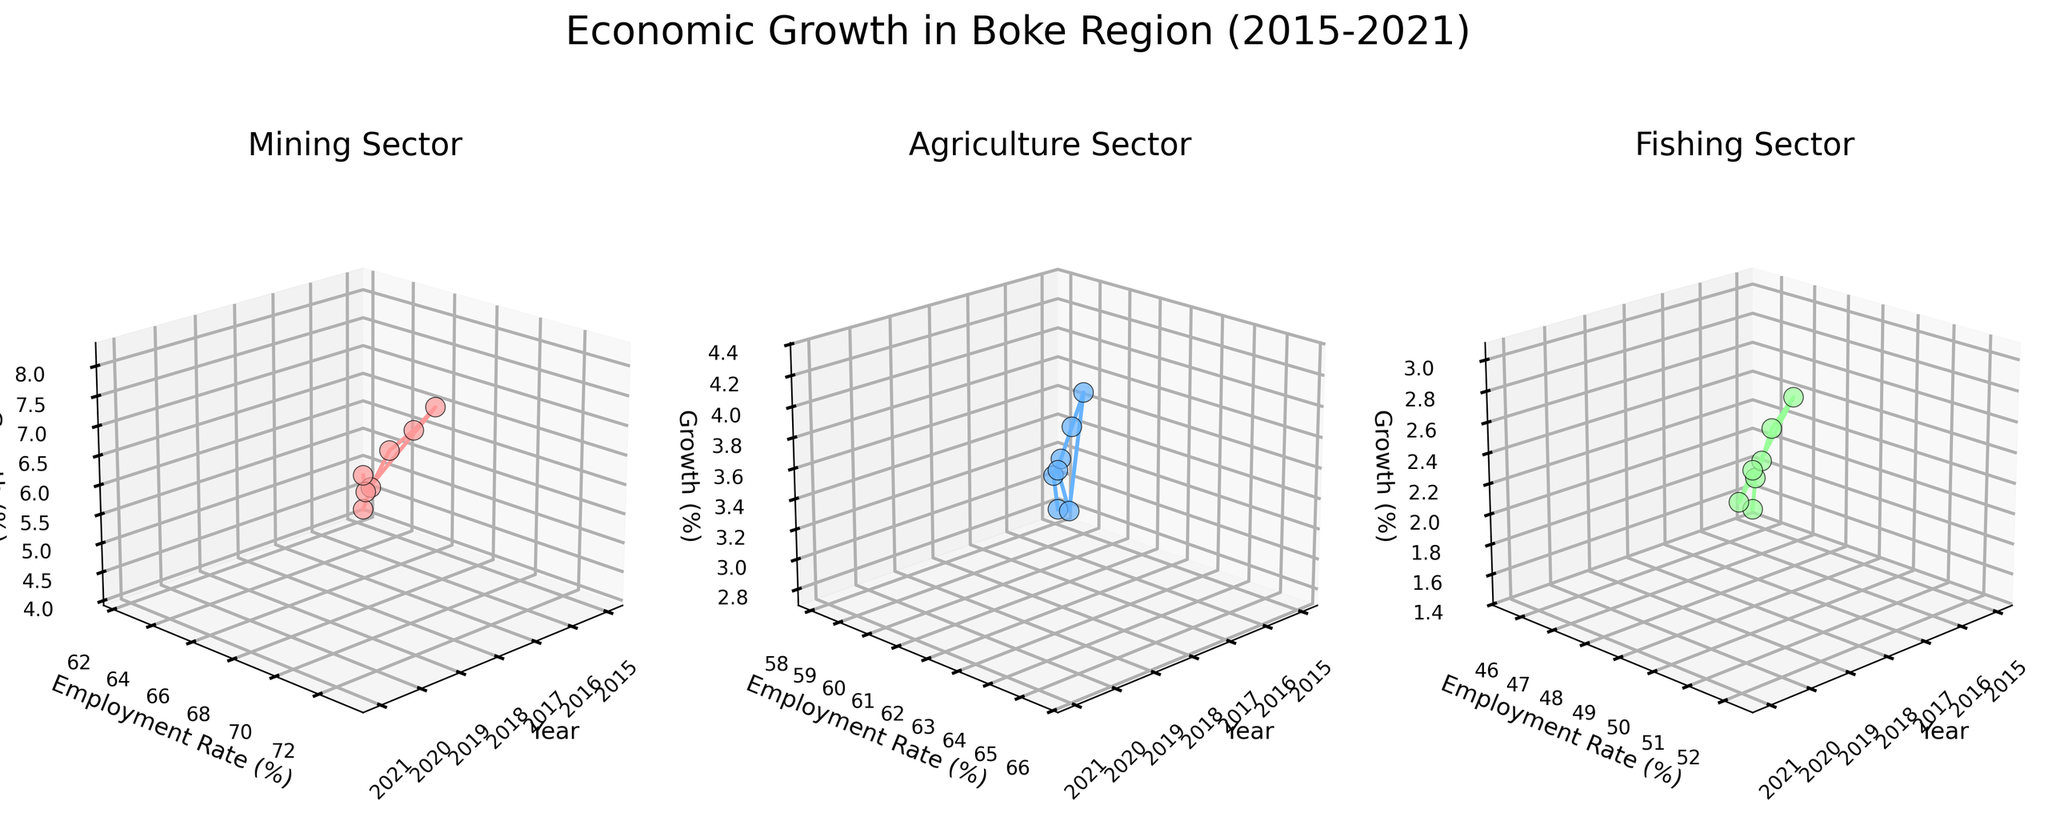What are the titles of the three subplots? The titles of the three subplots can be seen at the top of each plot area. The first subplot is titled "Mining Sector," the second subplot is titled "Agriculture Sector," and the third subplot is titled "Fishing Sector."
Answer: Mining Sector, Agriculture Sector, Fishing Sector Which sector had the highest employment rate in 2021? By looking at the 2021 data points in each subplot, the Mining sector had the highest employment rate, as seen by the higher position along the Employment Rate axis.
Answer: Mining How did the growth percentage for the Agriculture sector change from 2015 to 2021? In the subplot for the Agriculture sector, trace the path of the data points from 2015 to 2021 along the Z-axis, which represents growth percentage. The growth percentage increased from 2.8 to 4.1.
Answer: Increased from 2.8 to 4.1 Which year had the highest growth percentage in the Mining sector? In the mining sector subplot, locate the data point with the highest position along the Z-axis (Growth Percentage). The highest growth percentage is seen in the year 2019.
Answer: 2019 Compare the employment rate in 2015 between Agriculture and Fishing sectors. Which one is higher? The employment rate for 2015 can be observed in the subplots of Agriculture and Fishing sectors. The Agriculture sector shows an employment rate of 58.1, while the Fishing sector shows 45.6. Agriculture is higher.
Answer: Agriculture What is the difference in growth percentage between 2016 and 2017 for the Fishing sector? In the Fishing sector subplot, locate the data points for the years 2016 and 2017 and observe their positions along the Z-axis. The growth percentage for 2016 is 1.9 and for 2017 is 2.2. The difference is 2.2 - 1.9 = 0.3.
Answer: 0.3 Which sector showed the most consistent increase in employment rate from 2015 to 2021? Examine the trend lines in each subplot along the Employment Rate axis. The Mining sector displays a consistently increasing trend line, indicating the most consistent increase in employment rate from 2015 to 2021.
Answer: Mining What are the employment rates for each sector in 2018? In each subplot, find the data points for the year 2018 and read the values along the Employment Rate axis. For Mining, it is 70.1%; for Agriculture, it is 62.3%; and for Fishing, it is 49.5%.
Answer: Mining: 70.1%, Agriculture: 62.3%, Fishing: 49.5% Which year had the lowest employment rate in the Mining sector? In the Mining sector subplot, locate the data point with the lowest position along the Employment Rate axis. The lowest employment rate is in the year 2015 with 62.3%.
Answer: 2015 